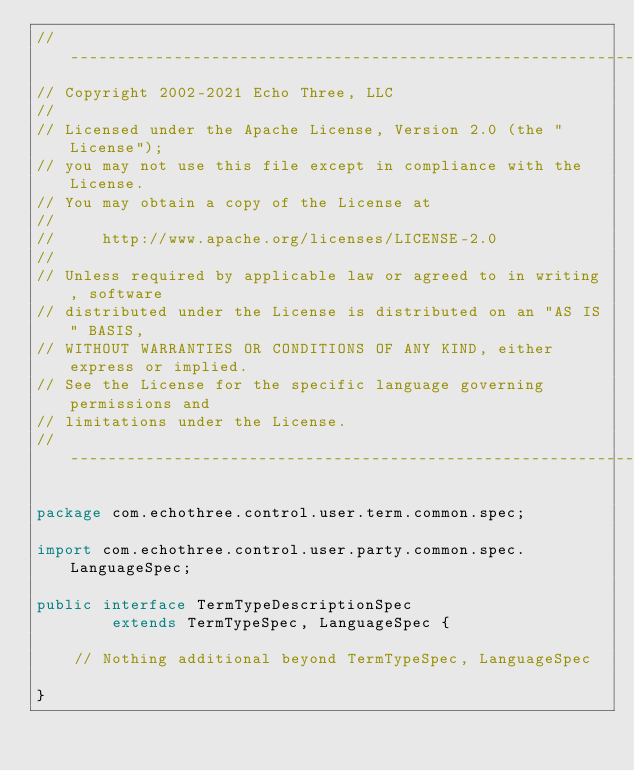Convert code to text. <code><loc_0><loc_0><loc_500><loc_500><_Java_>// --------------------------------------------------------------------------------
// Copyright 2002-2021 Echo Three, LLC
//
// Licensed under the Apache License, Version 2.0 (the "License");
// you may not use this file except in compliance with the License.
// You may obtain a copy of the License at
//
//     http://www.apache.org/licenses/LICENSE-2.0
//
// Unless required by applicable law or agreed to in writing, software
// distributed under the License is distributed on an "AS IS" BASIS,
// WITHOUT WARRANTIES OR CONDITIONS OF ANY KIND, either express or implied.
// See the License for the specific language governing permissions and
// limitations under the License.
// --------------------------------------------------------------------------------

package com.echothree.control.user.term.common.spec;

import com.echothree.control.user.party.common.spec.LanguageSpec;

public interface TermTypeDescriptionSpec
        extends TermTypeSpec, LanguageSpec {
    
    // Nothing additional beyond TermTypeSpec, LanguageSpec
    
}
</code> 